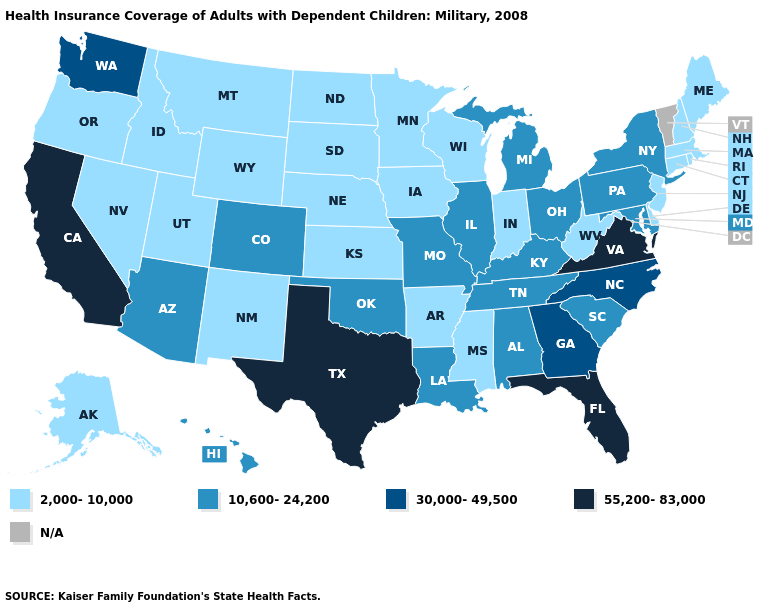Among the states that border Utah , does Wyoming have the lowest value?
Write a very short answer. Yes. What is the lowest value in states that border New York?
Quick response, please. 2,000-10,000. What is the lowest value in the West?
Short answer required. 2,000-10,000. What is the highest value in states that border New Mexico?
Write a very short answer. 55,200-83,000. What is the highest value in the USA?
Write a very short answer. 55,200-83,000. Does Nebraska have the highest value in the MidWest?
Give a very brief answer. No. Name the states that have a value in the range 10,600-24,200?
Short answer required. Alabama, Arizona, Colorado, Hawaii, Illinois, Kentucky, Louisiana, Maryland, Michigan, Missouri, New York, Ohio, Oklahoma, Pennsylvania, South Carolina, Tennessee. Does the map have missing data?
Be succinct. Yes. What is the value of Florida?
Write a very short answer. 55,200-83,000. How many symbols are there in the legend?
Keep it brief. 5. Name the states that have a value in the range 2,000-10,000?
Give a very brief answer. Alaska, Arkansas, Connecticut, Delaware, Idaho, Indiana, Iowa, Kansas, Maine, Massachusetts, Minnesota, Mississippi, Montana, Nebraska, Nevada, New Hampshire, New Jersey, New Mexico, North Dakota, Oregon, Rhode Island, South Dakota, Utah, West Virginia, Wisconsin, Wyoming. Does Pennsylvania have the lowest value in the Northeast?
Keep it brief. No. Name the states that have a value in the range 10,600-24,200?
Answer briefly. Alabama, Arizona, Colorado, Hawaii, Illinois, Kentucky, Louisiana, Maryland, Michigan, Missouri, New York, Ohio, Oklahoma, Pennsylvania, South Carolina, Tennessee. Which states have the lowest value in the USA?
Keep it brief. Alaska, Arkansas, Connecticut, Delaware, Idaho, Indiana, Iowa, Kansas, Maine, Massachusetts, Minnesota, Mississippi, Montana, Nebraska, Nevada, New Hampshire, New Jersey, New Mexico, North Dakota, Oregon, Rhode Island, South Dakota, Utah, West Virginia, Wisconsin, Wyoming. 